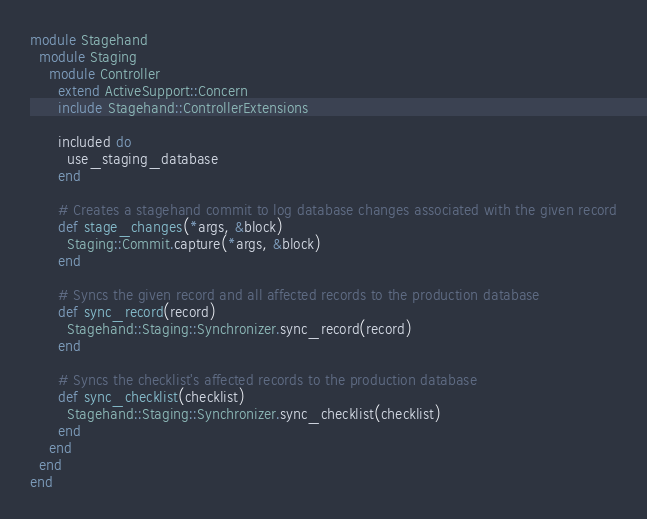Convert code to text. <code><loc_0><loc_0><loc_500><loc_500><_Ruby_>module Stagehand
  module Staging
    module Controller
      extend ActiveSupport::Concern
      include Stagehand::ControllerExtensions

      included do
        use_staging_database
      end

      # Creates a stagehand commit to log database changes associated with the given record
      def stage_changes(*args, &block)
        Staging::Commit.capture(*args, &block)
      end

      # Syncs the given record and all affected records to the production database
      def sync_record(record)
        Stagehand::Staging::Synchronizer.sync_record(record)
      end

      # Syncs the checklist's affected records to the production database
      def sync_checklist(checklist)
        Stagehand::Staging::Synchronizer.sync_checklist(checklist)
      end
    end
  end
end
</code> 